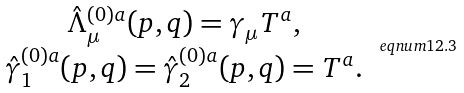<formula> <loc_0><loc_0><loc_500><loc_500>\begin{array} { c } \hat { \Lambda } _ { \mu } ^ { ( 0 ) a } ( p , q ) = \gamma _ { \mu } T ^ { a } , \\ \hat { \gamma } _ { 1 } ^ { ( 0 ) a } ( p , q ) = \hat { \gamma } _ { 2 } ^ { ( 0 ) a } ( p , q ) = T ^ { a } . \end{array} \ e q n u m { 1 2 . 3 }</formula> 